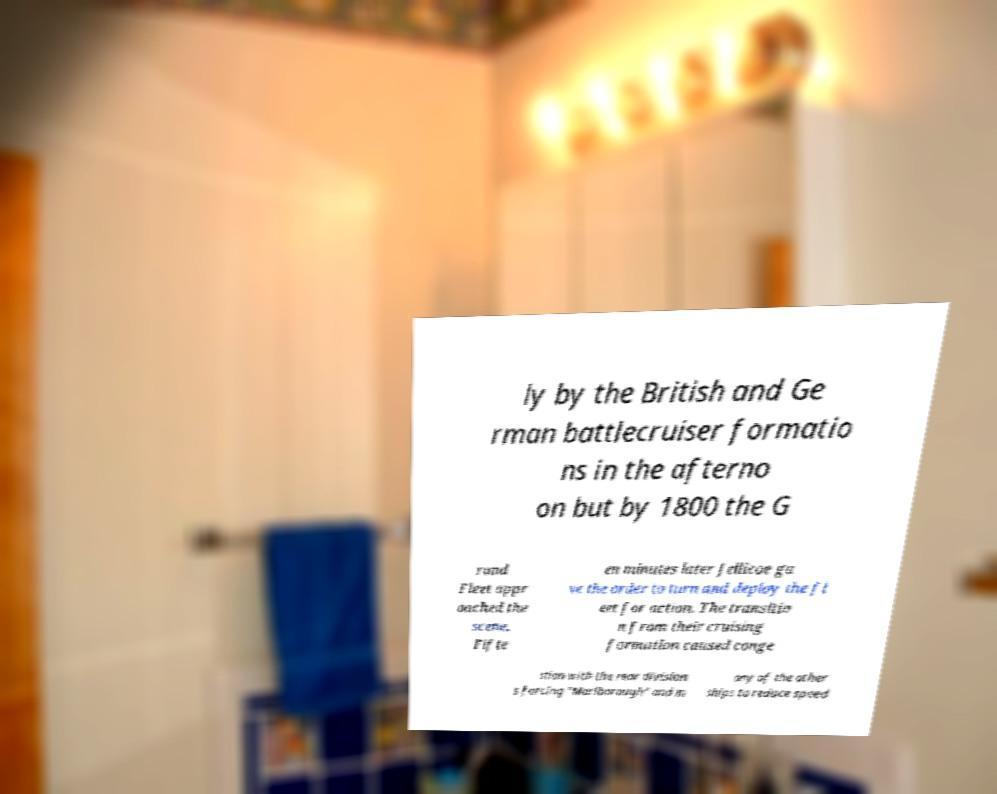I need the written content from this picture converted into text. Can you do that? ly by the British and Ge rman battlecruiser formatio ns in the afterno on but by 1800 the G rand Fleet appr oached the scene. Fifte en minutes later Jellicoe ga ve the order to turn and deploy the fl eet for action. The transitio n from their cruising formation caused conge stion with the rear division s forcing "Marlborough" and m any of the other ships to reduce speed 